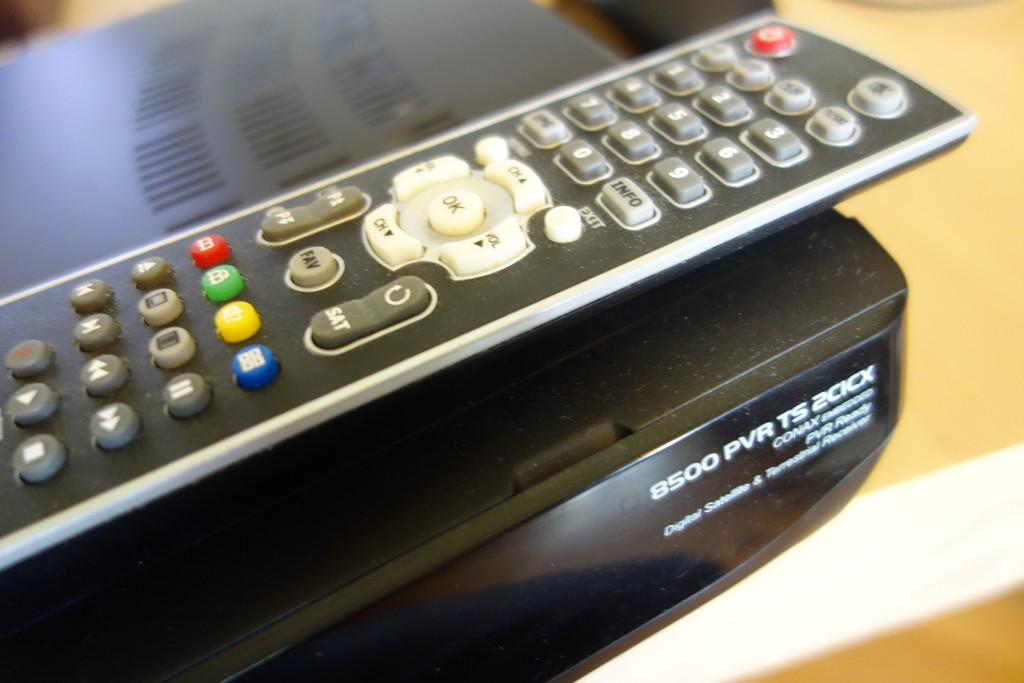<image>
Share a concise interpretation of the image provided. A remote control is sitting on top of a 8500 PVR TS 2CICX digital satellite and terrestrial receiver. 